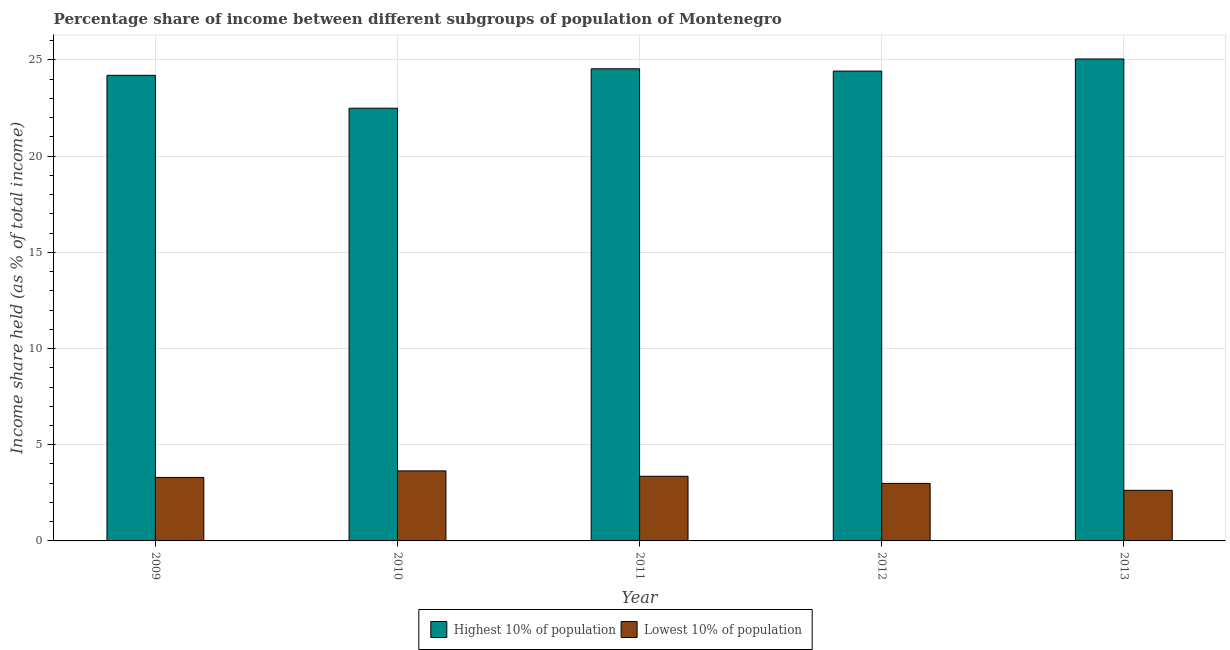How many different coloured bars are there?
Your answer should be compact. 2. How many groups of bars are there?
Give a very brief answer. 5. Are the number of bars per tick equal to the number of legend labels?
Keep it short and to the point. Yes. What is the label of the 5th group of bars from the left?
Offer a very short reply. 2013. What is the income share held by highest 10% of the population in 2011?
Provide a succinct answer. 24.54. Across all years, what is the maximum income share held by lowest 10% of the population?
Your answer should be very brief. 3.64. Across all years, what is the minimum income share held by highest 10% of the population?
Your response must be concise. 22.49. In which year was the income share held by lowest 10% of the population maximum?
Your answer should be very brief. 2010. What is the total income share held by highest 10% of the population in the graph?
Provide a succinct answer. 120.7. What is the difference between the income share held by lowest 10% of the population in 2009 and that in 2010?
Offer a terse response. -0.34. What is the difference between the income share held by highest 10% of the population in 2011 and the income share held by lowest 10% of the population in 2013?
Give a very brief answer. -0.51. What is the average income share held by lowest 10% of the population per year?
Keep it short and to the point. 3.18. In how many years, is the income share held by lowest 10% of the population greater than 19 %?
Your answer should be very brief. 0. What is the ratio of the income share held by lowest 10% of the population in 2012 to that in 2013?
Keep it short and to the point. 1.14. Is the income share held by highest 10% of the population in 2009 less than that in 2010?
Provide a short and direct response. No. Is the difference between the income share held by highest 10% of the population in 2010 and 2012 greater than the difference between the income share held by lowest 10% of the population in 2010 and 2012?
Your answer should be very brief. No. What is the difference between the highest and the second highest income share held by lowest 10% of the population?
Offer a very short reply. 0.28. What is the difference between the highest and the lowest income share held by lowest 10% of the population?
Ensure brevity in your answer.  1.01. In how many years, is the income share held by highest 10% of the population greater than the average income share held by highest 10% of the population taken over all years?
Ensure brevity in your answer.  4. What does the 2nd bar from the left in 2013 represents?
Offer a very short reply. Lowest 10% of population. What does the 2nd bar from the right in 2011 represents?
Provide a succinct answer. Highest 10% of population. How many bars are there?
Keep it short and to the point. 10. Are all the bars in the graph horizontal?
Provide a succinct answer. No. Where does the legend appear in the graph?
Offer a terse response. Bottom center. How many legend labels are there?
Your answer should be compact. 2. What is the title of the graph?
Provide a succinct answer. Percentage share of income between different subgroups of population of Montenegro. Does "Lowest 20% of population" appear as one of the legend labels in the graph?
Provide a succinct answer. No. What is the label or title of the X-axis?
Provide a short and direct response. Year. What is the label or title of the Y-axis?
Give a very brief answer. Income share held (as % of total income). What is the Income share held (as % of total income) of Highest 10% of population in 2009?
Offer a terse response. 24.2. What is the Income share held (as % of total income) in Lowest 10% of population in 2009?
Provide a succinct answer. 3.3. What is the Income share held (as % of total income) in Highest 10% of population in 2010?
Give a very brief answer. 22.49. What is the Income share held (as % of total income) of Lowest 10% of population in 2010?
Provide a short and direct response. 3.64. What is the Income share held (as % of total income) of Highest 10% of population in 2011?
Ensure brevity in your answer.  24.54. What is the Income share held (as % of total income) of Lowest 10% of population in 2011?
Your answer should be very brief. 3.36. What is the Income share held (as % of total income) of Highest 10% of population in 2012?
Offer a terse response. 24.42. What is the Income share held (as % of total income) of Lowest 10% of population in 2012?
Ensure brevity in your answer.  2.99. What is the Income share held (as % of total income) of Highest 10% of population in 2013?
Your answer should be compact. 25.05. What is the Income share held (as % of total income) in Lowest 10% of population in 2013?
Ensure brevity in your answer.  2.63. Across all years, what is the maximum Income share held (as % of total income) in Highest 10% of population?
Provide a succinct answer. 25.05. Across all years, what is the maximum Income share held (as % of total income) in Lowest 10% of population?
Your answer should be compact. 3.64. Across all years, what is the minimum Income share held (as % of total income) of Highest 10% of population?
Offer a very short reply. 22.49. Across all years, what is the minimum Income share held (as % of total income) in Lowest 10% of population?
Ensure brevity in your answer.  2.63. What is the total Income share held (as % of total income) of Highest 10% of population in the graph?
Provide a short and direct response. 120.7. What is the total Income share held (as % of total income) in Lowest 10% of population in the graph?
Your response must be concise. 15.92. What is the difference between the Income share held (as % of total income) in Highest 10% of population in 2009 and that in 2010?
Provide a short and direct response. 1.71. What is the difference between the Income share held (as % of total income) in Lowest 10% of population in 2009 and that in 2010?
Offer a very short reply. -0.34. What is the difference between the Income share held (as % of total income) in Highest 10% of population in 2009 and that in 2011?
Offer a terse response. -0.34. What is the difference between the Income share held (as % of total income) in Lowest 10% of population in 2009 and that in 2011?
Make the answer very short. -0.06. What is the difference between the Income share held (as % of total income) of Highest 10% of population in 2009 and that in 2012?
Provide a short and direct response. -0.22. What is the difference between the Income share held (as % of total income) of Lowest 10% of population in 2009 and that in 2012?
Provide a short and direct response. 0.31. What is the difference between the Income share held (as % of total income) in Highest 10% of population in 2009 and that in 2013?
Provide a short and direct response. -0.85. What is the difference between the Income share held (as % of total income) of Lowest 10% of population in 2009 and that in 2013?
Offer a very short reply. 0.67. What is the difference between the Income share held (as % of total income) in Highest 10% of population in 2010 and that in 2011?
Your answer should be compact. -2.05. What is the difference between the Income share held (as % of total income) of Lowest 10% of population in 2010 and that in 2011?
Offer a very short reply. 0.28. What is the difference between the Income share held (as % of total income) of Highest 10% of population in 2010 and that in 2012?
Ensure brevity in your answer.  -1.93. What is the difference between the Income share held (as % of total income) in Lowest 10% of population in 2010 and that in 2012?
Ensure brevity in your answer.  0.65. What is the difference between the Income share held (as % of total income) of Highest 10% of population in 2010 and that in 2013?
Give a very brief answer. -2.56. What is the difference between the Income share held (as % of total income) in Lowest 10% of population in 2010 and that in 2013?
Your answer should be very brief. 1.01. What is the difference between the Income share held (as % of total income) in Highest 10% of population in 2011 and that in 2012?
Keep it short and to the point. 0.12. What is the difference between the Income share held (as % of total income) in Lowest 10% of population in 2011 and that in 2012?
Your answer should be compact. 0.37. What is the difference between the Income share held (as % of total income) in Highest 10% of population in 2011 and that in 2013?
Your answer should be compact. -0.51. What is the difference between the Income share held (as % of total income) in Lowest 10% of population in 2011 and that in 2013?
Your response must be concise. 0.73. What is the difference between the Income share held (as % of total income) of Highest 10% of population in 2012 and that in 2013?
Give a very brief answer. -0.63. What is the difference between the Income share held (as % of total income) of Lowest 10% of population in 2012 and that in 2013?
Your answer should be very brief. 0.36. What is the difference between the Income share held (as % of total income) of Highest 10% of population in 2009 and the Income share held (as % of total income) of Lowest 10% of population in 2010?
Keep it short and to the point. 20.56. What is the difference between the Income share held (as % of total income) in Highest 10% of population in 2009 and the Income share held (as % of total income) in Lowest 10% of population in 2011?
Your response must be concise. 20.84. What is the difference between the Income share held (as % of total income) of Highest 10% of population in 2009 and the Income share held (as % of total income) of Lowest 10% of population in 2012?
Your response must be concise. 21.21. What is the difference between the Income share held (as % of total income) in Highest 10% of population in 2009 and the Income share held (as % of total income) in Lowest 10% of population in 2013?
Offer a terse response. 21.57. What is the difference between the Income share held (as % of total income) in Highest 10% of population in 2010 and the Income share held (as % of total income) in Lowest 10% of population in 2011?
Your response must be concise. 19.13. What is the difference between the Income share held (as % of total income) of Highest 10% of population in 2010 and the Income share held (as % of total income) of Lowest 10% of population in 2012?
Make the answer very short. 19.5. What is the difference between the Income share held (as % of total income) in Highest 10% of population in 2010 and the Income share held (as % of total income) in Lowest 10% of population in 2013?
Provide a succinct answer. 19.86. What is the difference between the Income share held (as % of total income) of Highest 10% of population in 2011 and the Income share held (as % of total income) of Lowest 10% of population in 2012?
Make the answer very short. 21.55. What is the difference between the Income share held (as % of total income) in Highest 10% of population in 2011 and the Income share held (as % of total income) in Lowest 10% of population in 2013?
Give a very brief answer. 21.91. What is the difference between the Income share held (as % of total income) of Highest 10% of population in 2012 and the Income share held (as % of total income) of Lowest 10% of population in 2013?
Provide a succinct answer. 21.79. What is the average Income share held (as % of total income) of Highest 10% of population per year?
Give a very brief answer. 24.14. What is the average Income share held (as % of total income) in Lowest 10% of population per year?
Offer a very short reply. 3.18. In the year 2009, what is the difference between the Income share held (as % of total income) in Highest 10% of population and Income share held (as % of total income) in Lowest 10% of population?
Your answer should be compact. 20.9. In the year 2010, what is the difference between the Income share held (as % of total income) in Highest 10% of population and Income share held (as % of total income) in Lowest 10% of population?
Make the answer very short. 18.85. In the year 2011, what is the difference between the Income share held (as % of total income) of Highest 10% of population and Income share held (as % of total income) of Lowest 10% of population?
Offer a very short reply. 21.18. In the year 2012, what is the difference between the Income share held (as % of total income) of Highest 10% of population and Income share held (as % of total income) of Lowest 10% of population?
Your response must be concise. 21.43. In the year 2013, what is the difference between the Income share held (as % of total income) of Highest 10% of population and Income share held (as % of total income) of Lowest 10% of population?
Your answer should be compact. 22.42. What is the ratio of the Income share held (as % of total income) in Highest 10% of population in 2009 to that in 2010?
Provide a succinct answer. 1.08. What is the ratio of the Income share held (as % of total income) of Lowest 10% of population in 2009 to that in 2010?
Your answer should be very brief. 0.91. What is the ratio of the Income share held (as % of total income) of Highest 10% of population in 2009 to that in 2011?
Keep it short and to the point. 0.99. What is the ratio of the Income share held (as % of total income) of Lowest 10% of population in 2009 to that in 2011?
Keep it short and to the point. 0.98. What is the ratio of the Income share held (as % of total income) of Highest 10% of population in 2009 to that in 2012?
Your response must be concise. 0.99. What is the ratio of the Income share held (as % of total income) of Lowest 10% of population in 2009 to that in 2012?
Provide a short and direct response. 1.1. What is the ratio of the Income share held (as % of total income) of Highest 10% of population in 2009 to that in 2013?
Make the answer very short. 0.97. What is the ratio of the Income share held (as % of total income) in Lowest 10% of population in 2009 to that in 2013?
Offer a very short reply. 1.25. What is the ratio of the Income share held (as % of total income) in Highest 10% of population in 2010 to that in 2011?
Provide a short and direct response. 0.92. What is the ratio of the Income share held (as % of total income) of Lowest 10% of population in 2010 to that in 2011?
Offer a terse response. 1.08. What is the ratio of the Income share held (as % of total income) of Highest 10% of population in 2010 to that in 2012?
Your answer should be very brief. 0.92. What is the ratio of the Income share held (as % of total income) of Lowest 10% of population in 2010 to that in 2012?
Your answer should be very brief. 1.22. What is the ratio of the Income share held (as % of total income) in Highest 10% of population in 2010 to that in 2013?
Give a very brief answer. 0.9. What is the ratio of the Income share held (as % of total income) in Lowest 10% of population in 2010 to that in 2013?
Keep it short and to the point. 1.38. What is the ratio of the Income share held (as % of total income) of Highest 10% of population in 2011 to that in 2012?
Ensure brevity in your answer.  1. What is the ratio of the Income share held (as % of total income) of Lowest 10% of population in 2011 to that in 2012?
Give a very brief answer. 1.12. What is the ratio of the Income share held (as % of total income) of Highest 10% of population in 2011 to that in 2013?
Provide a short and direct response. 0.98. What is the ratio of the Income share held (as % of total income) of Lowest 10% of population in 2011 to that in 2013?
Make the answer very short. 1.28. What is the ratio of the Income share held (as % of total income) in Highest 10% of population in 2012 to that in 2013?
Keep it short and to the point. 0.97. What is the ratio of the Income share held (as % of total income) in Lowest 10% of population in 2012 to that in 2013?
Your response must be concise. 1.14. What is the difference between the highest and the second highest Income share held (as % of total income) of Highest 10% of population?
Keep it short and to the point. 0.51. What is the difference between the highest and the second highest Income share held (as % of total income) in Lowest 10% of population?
Offer a very short reply. 0.28. What is the difference between the highest and the lowest Income share held (as % of total income) in Highest 10% of population?
Your answer should be compact. 2.56. 